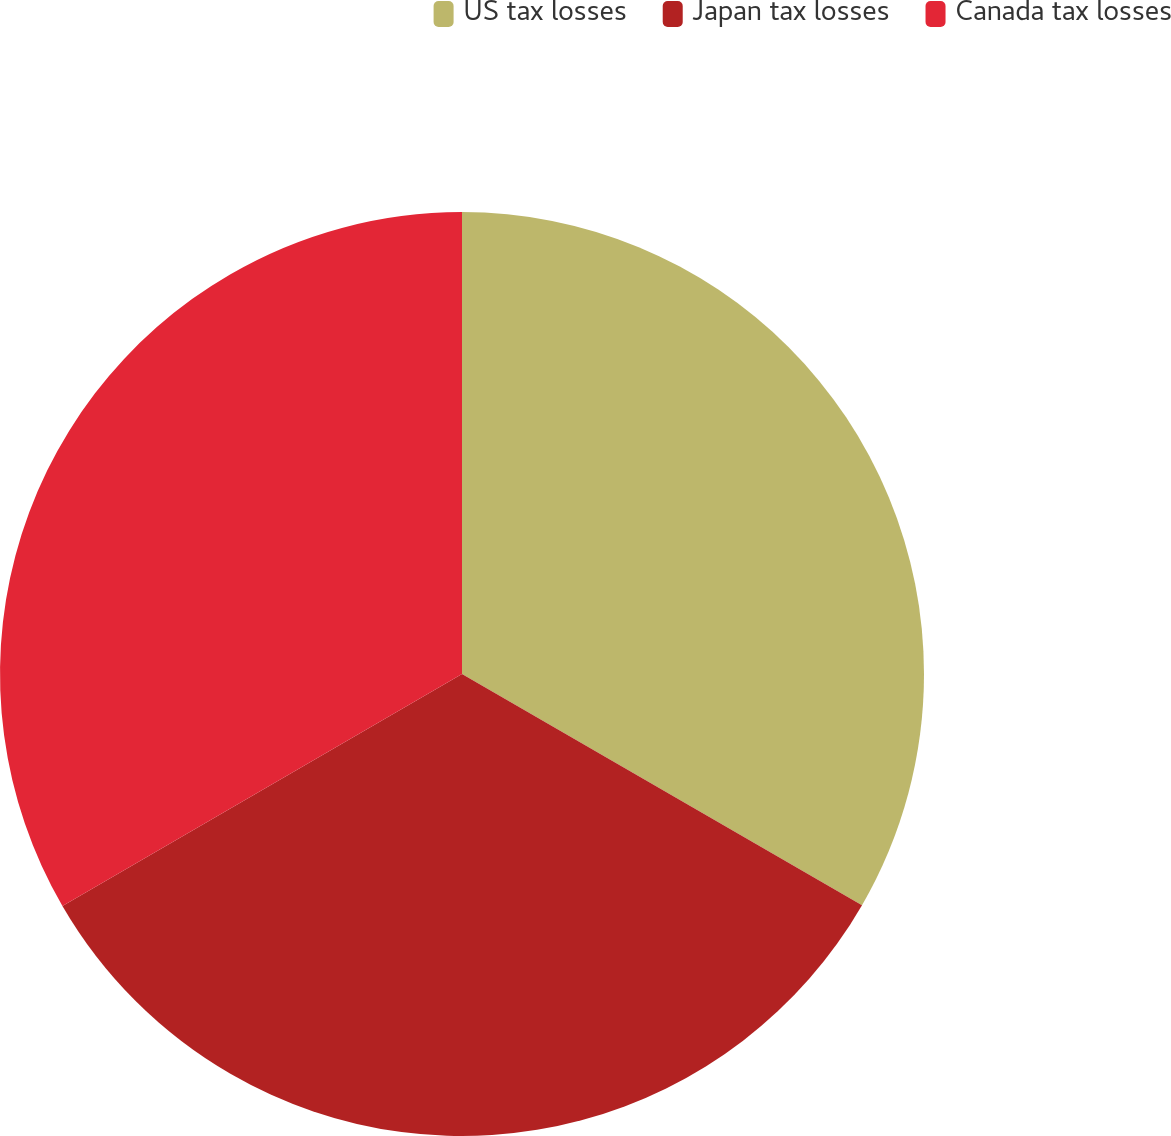<chart> <loc_0><loc_0><loc_500><loc_500><pie_chart><fcel>US tax losses<fcel>Japan tax losses<fcel>Canada tax losses<nl><fcel>33.34%<fcel>33.29%<fcel>33.37%<nl></chart> 